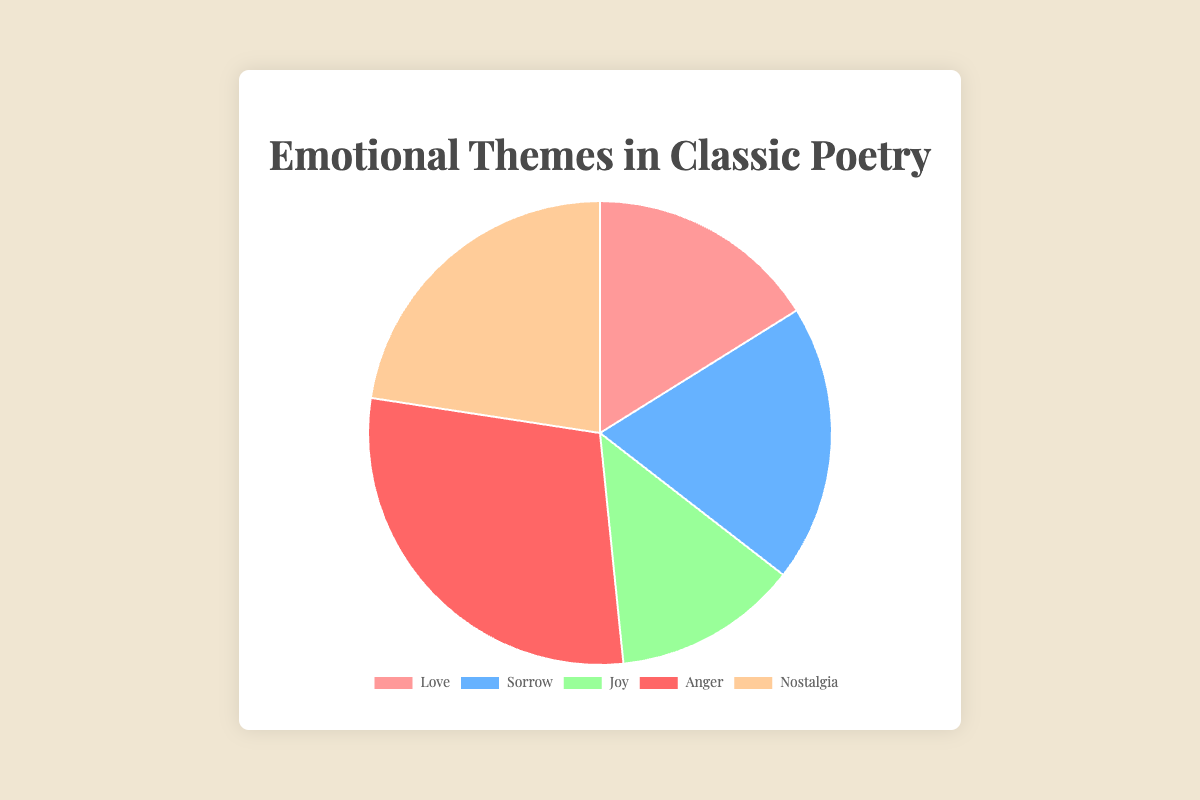What is the most common emotional theme depicted in classic poetry according to the chart? The chart shows various themes represented by different colored segments. The largest segment corresponds to "Anger," indicating it has the highest percentage among the themes.
Answer: Anger Which two emotional themes together make up more than half of the total percentage? Add the percentages of each theme: Love (25%), Sorrow (30%), Joy (20%), Anger (45%), Nostalgia (35%). The themes that together exceed 50% are "Anger" and "Nostalgia" which total 80%.
Answer: Anger and Nostalgia What is the combined percentage of poems dealing with Joy and Sorrow? Calculate the sum of the percentages for "Joy" and "Sorrow". Joy is 20%, and Sorrow is 30%. Their combined percentage is 20 + 30 = 50%.
Answer: 50% Is the percentage of Love themes greater than that of Nostalgia? Comparing the segments, Love is 25% and Nostalgia is 35%. Since 25% is less than 35%, Love is not greater than Nostalgia.
Answer: No What percentual difference exists between the themes of Anger and Joy? Subtract the percentage of Joy from Anger. Anger is 45%, and Joy is 20%. The difference is 45 - 20 = 25%.
Answer: 25% What color represents the theme with the lowest percentage, and what is that percentage? Observe the chart where different themes are color-coded. The smallest segment is "Joy" which has a percentage of 20% and is represented by green.
Answer: Green, 20% Considering the proportions, which emotional theme is least represented compared to Sorrow? Use the chart to find percentages: Sorrow has 30%, while Joy (20%) is lesser, making it the least represented compared to Sorrow.
Answer: Joy Combine the percentages of Love, Joy, and Anger. How does this sum compare to the total percentage of all the themes? First, sum the percentages: Love (25%) + Joy (20%) + Anger (45%) = 90%. Total of all themes is 100%. These three themes alone comprise 90% of the total.
Answer: 90% which is 10% less than the total Which emotional theme is represented by the fourth segment in the pie chart? Identify the order of segments in the visual representation. The fourth segment, going clockwise, corresponds to "Anger".
Answer: Anger Out of Love and Nostalgia, which theme has a lesser percentage and by how much? Compare the two: Love is 25% and Nostalgia is 35%. The difference is 35 - 25 = 10%.
Answer: Love by 10% 